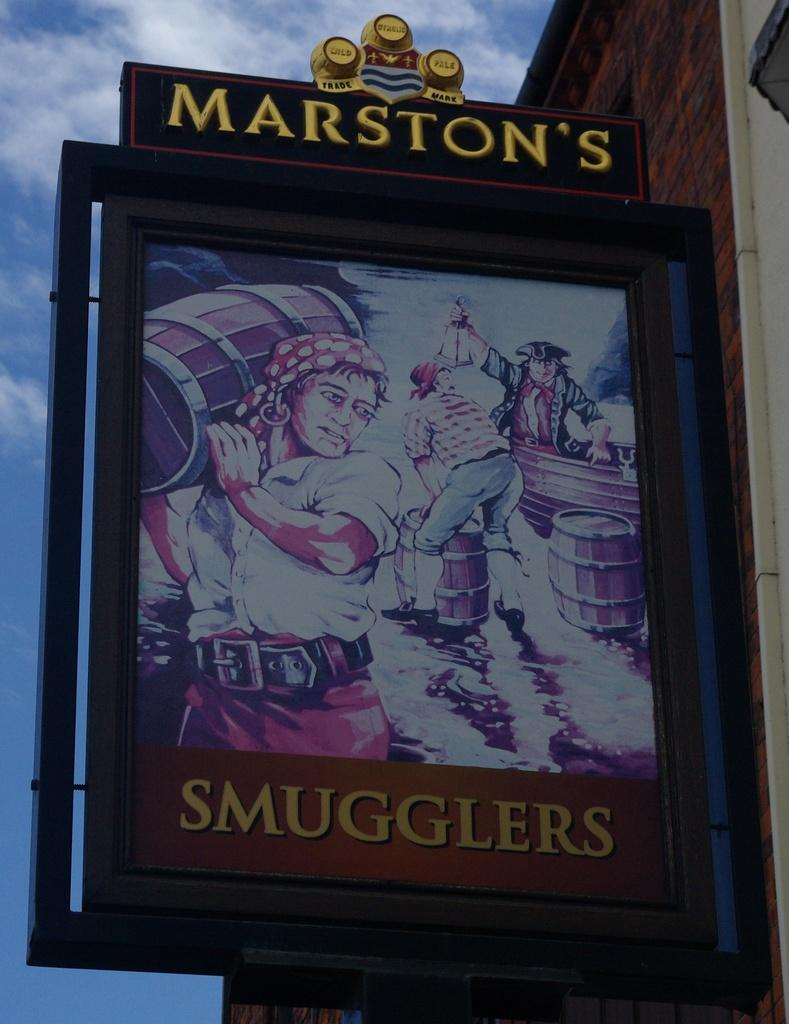Provide a one-sentence caption for the provided image. Marston's Smugglers is displayed on this old time pub advertisement. 